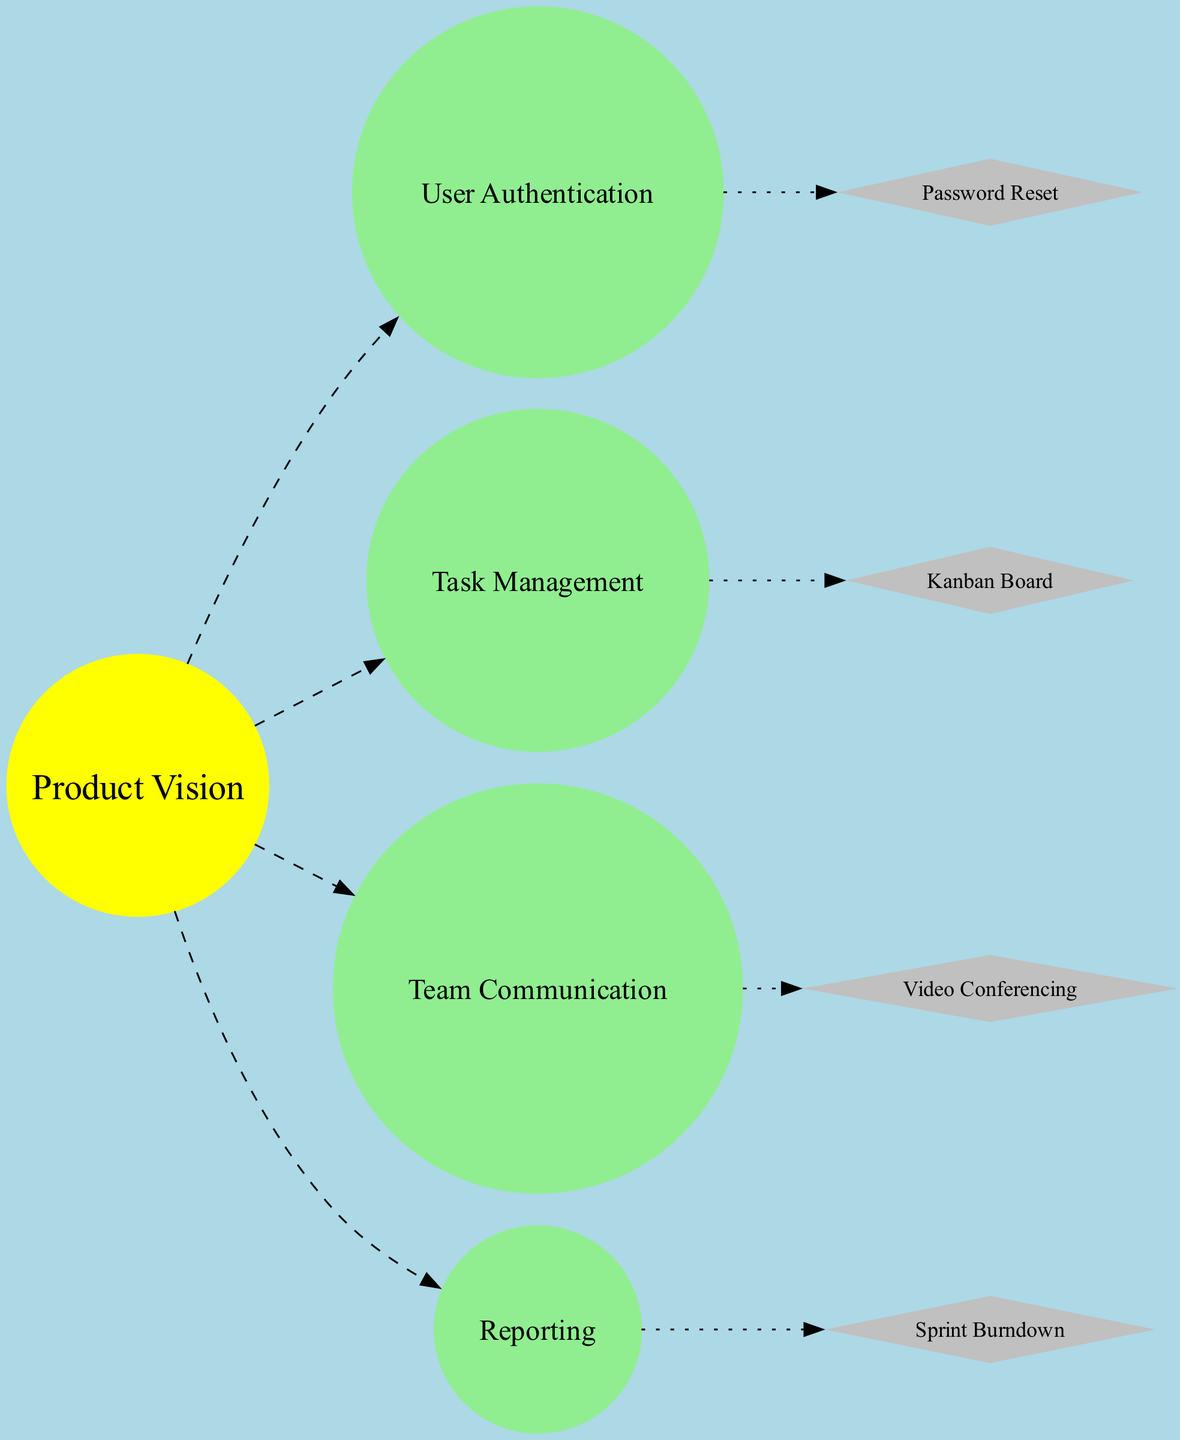What is the central element of the diagram? The central element, depicted as the sun, represents the product vision, which articulates the purpose of the product. This is confirmed by examining the node labeled "Product Vision."
Answer: Product Vision How many planets (epics) are shown in the diagram? By counting the nodes categorized as planets, we find there are four distinct epic nodes: User Authentication, Task Management, Team Communication, and Reporting. Thus, the total is four.
Answer: 4 What color represents the asteroids (user stories) in the diagram? The asteroids are illustrated in gray, as indicated by the color property of the nodes associated with user stories.
Answer: Gray Which planet (epic) is connected to the asteroid "Password Reset"? To find the connection, I look at the nearest planet in the list of planets and the specified asteroid. Since the first asteroid connects to the first planet based on the specified pattern, "Password Reset" is connected to "User Authentication."
Answer: User Authentication How are the planets (epics) connected to the product vision (sun)? The connection is established through dashed edges leading from each planet node directly to the sun node, highlighting the relationship between each epic and the product vision.
Answer: Dashed edges Which asteroid (user story) is linked to the "Task Management" planet? By examining the connections, the second asteroid, "Kanban Board," connects to "Task Management" according to the established pattern of connection based on their ordering.
Answer: Kanban Board How many asteroids (user stories) orbit around the planets (epics) in the diagram? The total number of asteroids listed is four, including Password Reset, Kanban Board, Video Conferencing, and Sprint Burndown, all orbiting around the respective epic planets.
Answer: 4 What is a function of the "Reporting" epic? According to the description provided for the Reporting epic, its function is to generate project progress reports. This can be found in the associated description of the Reporting planet.
Answer: Generate project progress reports Which user story is connected to "Team Communication"? The user story "Video Conferencing" is associated with "Team Communication," as it follows the sequence where the index indicates the corresponding planet.
Answer: Video Conferencing What type of edge connects the asteroids to the planets? The connections from asteroids to their respective planets are represented by dotted edges, indicating a different kind of relationship compared to the planets' connection to the sun.
Answer: Dotted edges 